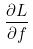<formula> <loc_0><loc_0><loc_500><loc_500>\frac { \partial L } { \partial f }</formula> 